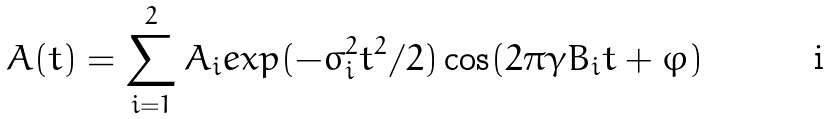<formula> <loc_0><loc_0><loc_500><loc_500>A ( t ) = \sum _ { i = 1 } ^ { 2 } A _ { i } e x p ( - \sigma ^ { 2 } _ { i } t ^ { 2 } / 2 ) \cos ( 2 \pi \gamma B _ { i } t + \varphi )</formula> 